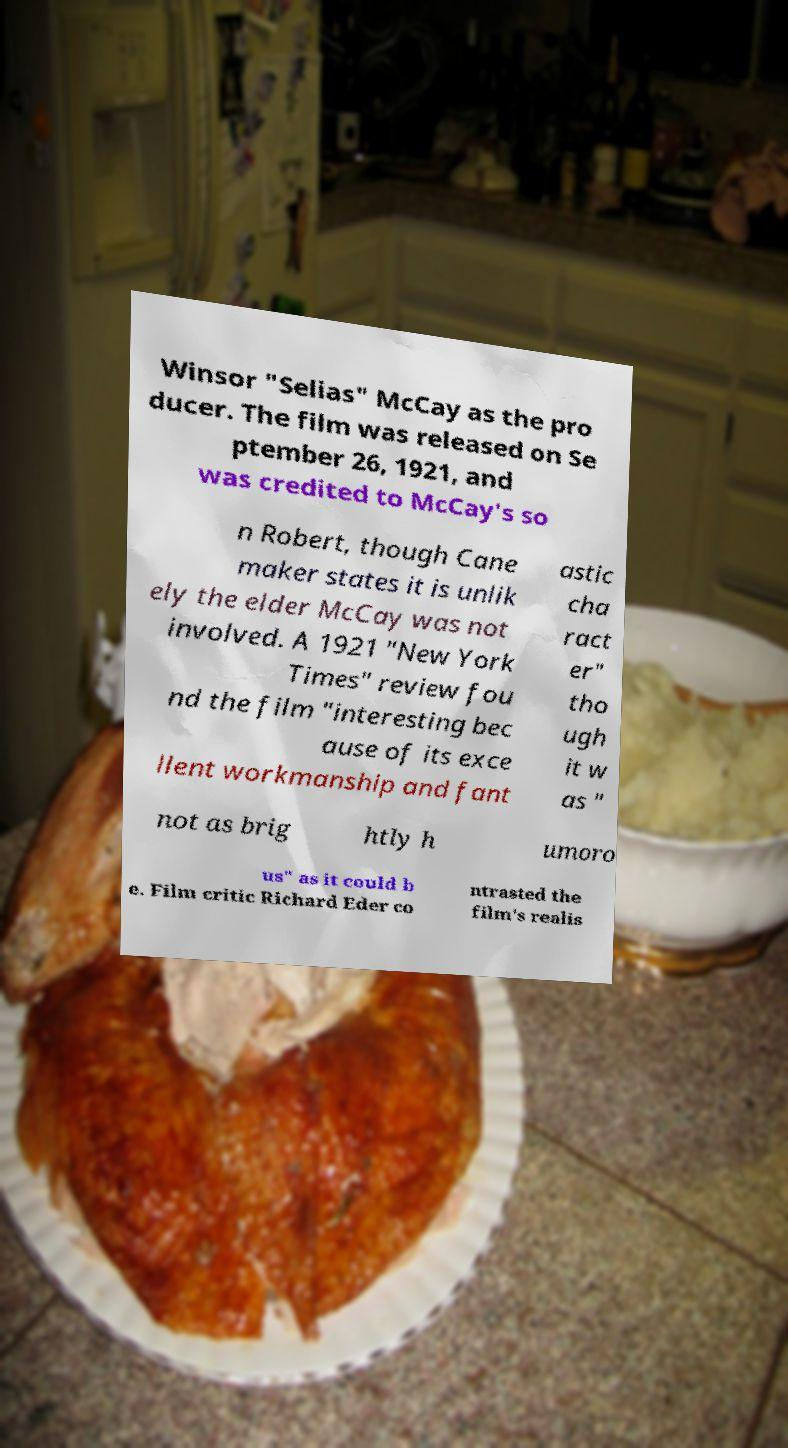Please read and relay the text visible in this image. What does it say? Winsor "Selias" McCay as the pro ducer. The film was released on Se ptember 26, 1921, and was credited to McCay's so n Robert, though Cane maker states it is unlik ely the elder McCay was not involved. A 1921 "New York Times" review fou nd the film "interesting bec ause of its exce llent workmanship and fant astic cha ract er" tho ugh it w as " not as brig htly h umoro us" as it could b e. Film critic Richard Eder co ntrasted the film's realis 